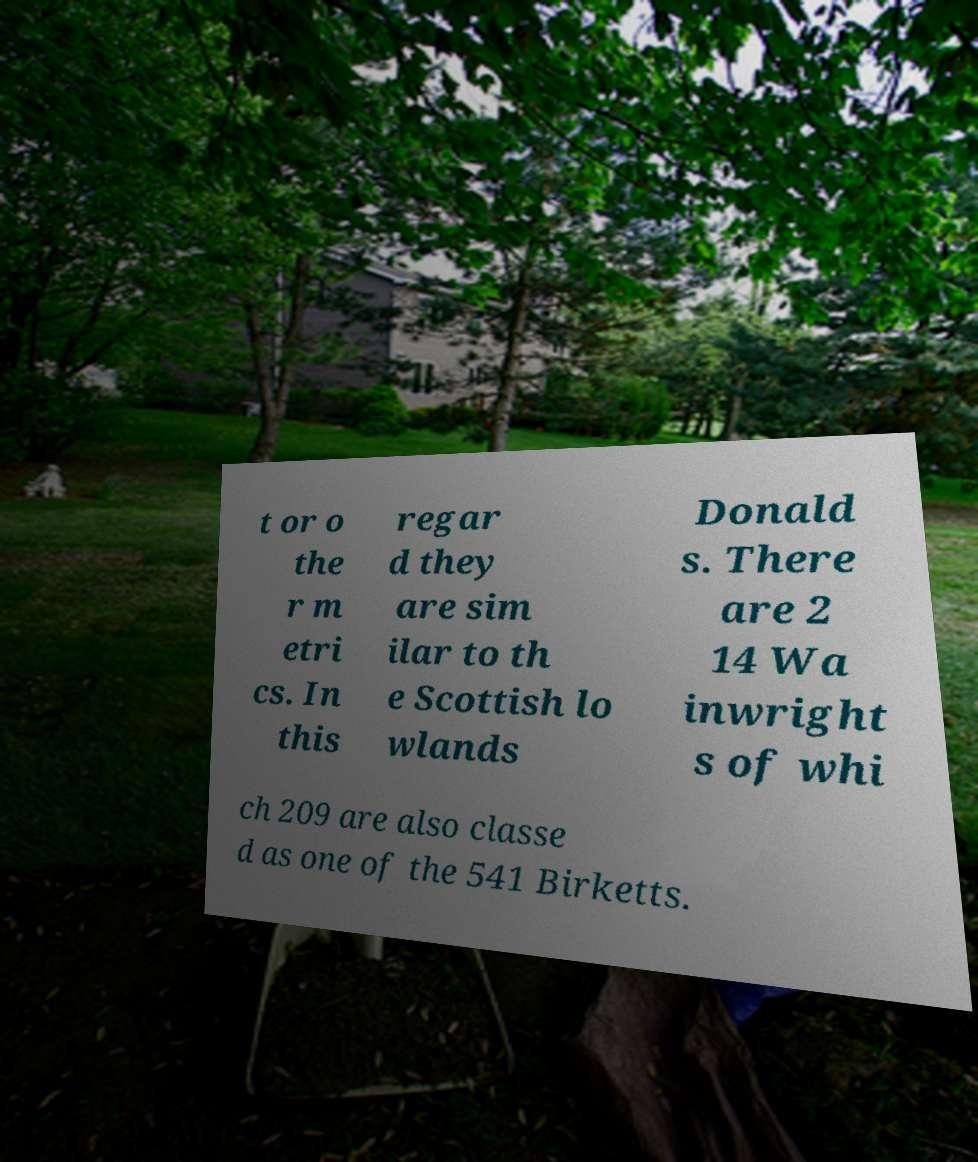Can you read and provide the text displayed in the image?This photo seems to have some interesting text. Can you extract and type it out for me? t or o the r m etri cs. In this regar d they are sim ilar to th e Scottish lo wlands Donald s. There are 2 14 Wa inwright s of whi ch 209 are also classe d as one of the 541 Birketts. 